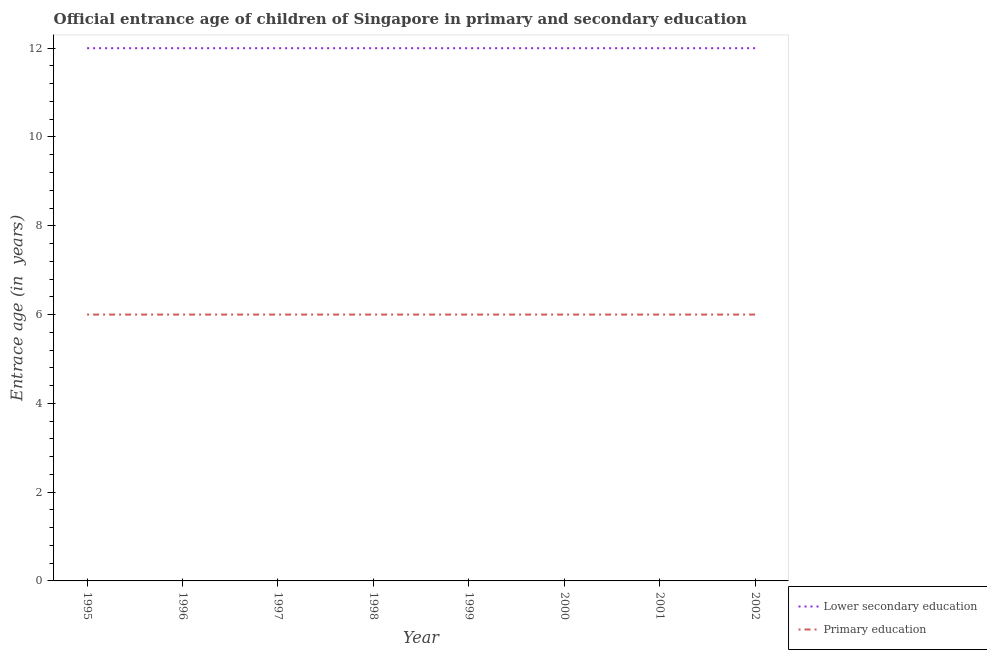How many different coloured lines are there?
Give a very brief answer. 2. Does the line corresponding to entrance age of children in lower secondary education intersect with the line corresponding to entrance age of chiildren in primary education?
Give a very brief answer. No. What is the entrance age of chiildren in primary education in 1995?
Provide a succinct answer. 6. Across all years, what is the maximum entrance age of children in lower secondary education?
Offer a terse response. 12. Across all years, what is the minimum entrance age of chiildren in primary education?
Offer a terse response. 6. What is the total entrance age of chiildren in primary education in the graph?
Your answer should be compact. 48. What is the difference between the entrance age of chiildren in primary education in 1999 and that in 2000?
Your response must be concise. 0. What is the difference between the entrance age of chiildren in primary education in 1996 and the entrance age of children in lower secondary education in 1999?
Your answer should be very brief. -6. What is the average entrance age of children in lower secondary education per year?
Your answer should be compact. 12. In the year 2000, what is the difference between the entrance age of chiildren in primary education and entrance age of children in lower secondary education?
Ensure brevity in your answer.  -6. In how many years, is the entrance age of children in lower secondary education greater than 6 years?
Offer a terse response. 8. Is the entrance age of children in lower secondary education in 1995 less than that in 1998?
Your response must be concise. No. What is the difference between the highest and the second highest entrance age of children in lower secondary education?
Keep it short and to the point. 0. Does the entrance age of chiildren in primary education monotonically increase over the years?
Your answer should be very brief. No. Is the entrance age of children in lower secondary education strictly less than the entrance age of chiildren in primary education over the years?
Your answer should be compact. No. How many years are there in the graph?
Offer a terse response. 8. What is the difference between two consecutive major ticks on the Y-axis?
Provide a short and direct response. 2. Are the values on the major ticks of Y-axis written in scientific E-notation?
Your response must be concise. No. Does the graph contain grids?
Offer a very short reply. No. How many legend labels are there?
Provide a short and direct response. 2. How are the legend labels stacked?
Your answer should be very brief. Vertical. What is the title of the graph?
Provide a short and direct response. Official entrance age of children of Singapore in primary and secondary education. What is the label or title of the Y-axis?
Provide a short and direct response. Entrace age (in  years). What is the Entrace age (in  years) in Lower secondary education in 1995?
Make the answer very short. 12. What is the Entrace age (in  years) in Lower secondary education in 2000?
Ensure brevity in your answer.  12. What is the Entrace age (in  years) in Lower secondary education in 2001?
Make the answer very short. 12. What is the Entrace age (in  years) of Lower secondary education in 2002?
Your response must be concise. 12. Across all years, what is the minimum Entrace age (in  years) in Primary education?
Provide a short and direct response. 6. What is the total Entrace age (in  years) of Lower secondary education in the graph?
Offer a very short reply. 96. What is the difference between the Entrace age (in  years) of Lower secondary education in 1995 and that in 1996?
Your answer should be very brief. 0. What is the difference between the Entrace age (in  years) in Primary education in 1995 and that in 1996?
Provide a short and direct response. 0. What is the difference between the Entrace age (in  years) in Primary education in 1995 and that in 1997?
Your answer should be very brief. 0. What is the difference between the Entrace age (in  years) in Lower secondary education in 1995 and that in 1998?
Give a very brief answer. 0. What is the difference between the Entrace age (in  years) of Primary education in 1995 and that in 1998?
Ensure brevity in your answer.  0. What is the difference between the Entrace age (in  years) of Primary education in 1995 and that in 1999?
Make the answer very short. 0. What is the difference between the Entrace age (in  years) of Lower secondary education in 1995 and that in 2000?
Your answer should be compact. 0. What is the difference between the Entrace age (in  years) of Lower secondary education in 1995 and that in 2001?
Give a very brief answer. 0. What is the difference between the Entrace age (in  years) of Primary education in 1995 and that in 2001?
Make the answer very short. 0. What is the difference between the Entrace age (in  years) in Lower secondary education in 1995 and that in 2002?
Give a very brief answer. 0. What is the difference between the Entrace age (in  years) in Primary education in 1996 and that in 1997?
Make the answer very short. 0. What is the difference between the Entrace age (in  years) in Lower secondary education in 1996 and that in 1999?
Give a very brief answer. 0. What is the difference between the Entrace age (in  years) of Lower secondary education in 1996 and that in 2000?
Give a very brief answer. 0. What is the difference between the Entrace age (in  years) in Lower secondary education in 1996 and that in 2002?
Your answer should be compact. 0. What is the difference between the Entrace age (in  years) of Lower secondary education in 1997 and that in 1998?
Keep it short and to the point. 0. What is the difference between the Entrace age (in  years) in Primary education in 1997 and that in 1998?
Make the answer very short. 0. What is the difference between the Entrace age (in  years) in Primary education in 1997 and that in 1999?
Keep it short and to the point. 0. What is the difference between the Entrace age (in  years) of Primary education in 1997 and that in 2000?
Your response must be concise. 0. What is the difference between the Entrace age (in  years) of Lower secondary education in 1997 and that in 2001?
Make the answer very short. 0. What is the difference between the Entrace age (in  years) of Lower secondary education in 1997 and that in 2002?
Provide a short and direct response. 0. What is the difference between the Entrace age (in  years) in Lower secondary education in 1998 and that in 1999?
Make the answer very short. 0. What is the difference between the Entrace age (in  years) in Primary education in 1998 and that in 2000?
Your answer should be very brief. 0. What is the difference between the Entrace age (in  years) of Lower secondary education in 1998 and that in 2001?
Keep it short and to the point. 0. What is the difference between the Entrace age (in  years) in Primary education in 1999 and that in 2002?
Ensure brevity in your answer.  0. What is the difference between the Entrace age (in  years) in Lower secondary education in 2000 and that in 2001?
Keep it short and to the point. 0. What is the difference between the Entrace age (in  years) of Primary education in 2000 and that in 2002?
Offer a terse response. 0. What is the difference between the Entrace age (in  years) in Lower secondary education in 1995 and the Entrace age (in  years) in Primary education in 1999?
Keep it short and to the point. 6. What is the difference between the Entrace age (in  years) in Lower secondary education in 1995 and the Entrace age (in  years) in Primary education in 2000?
Keep it short and to the point. 6. What is the difference between the Entrace age (in  years) in Lower secondary education in 1995 and the Entrace age (in  years) in Primary education in 2001?
Your response must be concise. 6. What is the difference between the Entrace age (in  years) in Lower secondary education in 1995 and the Entrace age (in  years) in Primary education in 2002?
Give a very brief answer. 6. What is the difference between the Entrace age (in  years) in Lower secondary education in 1996 and the Entrace age (in  years) in Primary education in 1998?
Your answer should be compact. 6. What is the difference between the Entrace age (in  years) of Lower secondary education in 1996 and the Entrace age (in  years) of Primary education in 1999?
Your response must be concise. 6. What is the difference between the Entrace age (in  years) of Lower secondary education in 1998 and the Entrace age (in  years) of Primary education in 1999?
Keep it short and to the point. 6. What is the difference between the Entrace age (in  years) of Lower secondary education in 1998 and the Entrace age (in  years) of Primary education in 2001?
Offer a very short reply. 6. What is the difference between the Entrace age (in  years) of Lower secondary education in 1998 and the Entrace age (in  years) of Primary education in 2002?
Offer a very short reply. 6. What is the difference between the Entrace age (in  years) of Lower secondary education in 1999 and the Entrace age (in  years) of Primary education in 2001?
Ensure brevity in your answer.  6. What is the difference between the Entrace age (in  years) of Lower secondary education in 1999 and the Entrace age (in  years) of Primary education in 2002?
Offer a very short reply. 6. What is the difference between the Entrace age (in  years) of Lower secondary education in 2000 and the Entrace age (in  years) of Primary education in 2001?
Your answer should be very brief. 6. What is the difference between the Entrace age (in  years) in Lower secondary education in 2000 and the Entrace age (in  years) in Primary education in 2002?
Provide a succinct answer. 6. What is the average Entrace age (in  years) in Lower secondary education per year?
Provide a succinct answer. 12. What is the average Entrace age (in  years) in Primary education per year?
Make the answer very short. 6. In the year 1995, what is the difference between the Entrace age (in  years) in Lower secondary education and Entrace age (in  years) in Primary education?
Your response must be concise. 6. In the year 1999, what is the difference between the Entrace age (in  years) of Lower secondary education and Entrace age (in  years) of Primary education?
Give a very brief answer. 6. What is the ratio of the Entrace age (in  years) of Primary education in 1995 to that in 1996?
Ensure brevity in your answer.  1. What is the ratio of the Entrace age (in  years) in Lower secondary education in 1995 to that in 1997?
Your answer should be compact. 1. What is the ratio of the Entrace age (in  years) of Primary education in 1995 to that in 1997?
Provide a succinct answer. 1. What is the ratio of the Entrace age (in  years) in Lower secondary education in 1995 to that in 2000?
Offer a very short reply. 1. What is the ratio of the Entrace age (in  years) of Lower secondary education in 1995 to that in 2001?
Your answer should be compact. 1. What is the ratio of the Entrace age (in  years) in Primary education in 1995 to that in 2001?
Keep it short and to the point. 1. What is the ratio of the Entrace age (in  years) in Primary education in 1995 to that in 2002?
Your answer should be compact. 1. What is the ratio of the Entrace age (in  years) in Lower secondary education in 1996 to that in 1997?
Make the answer very short. 1. What is the ratio of the Entrace age (in  years) in Primary education in 1996 to that in 1997?
Your answer should be compact. 1. What is the ratio of the Entrace age (in  years) in Primary education in 1996 to that in 1998?
Your response must be concise. 1. What is the ratio of the Entrace age (in  years) of Primary education in 1996 to that in 1999?
Provide a succinct answer. 1. What is the ratio of the Entrace age (in  years) of Lower secondary education in 1996 to that in 2000?
Provide a short and direct response. 1. What is the ratio of the Entrace age (in  years) of Primary education in 1996 to that in 2000?
Provide a succinct answer. 1. What is the ratio of the Entrace age (in  years) of Lower secondary education in 1996 to that in 2001?
Give a very brief answer. 1. What is the ratio of the Entrace age (in  years) of Primary education in 1996 to that in 2001?
Your answer should be very brief. 1. What is the ratio of the Entrace age (in  years) of Primary education in 1996 to that in 2002?
Make the answer very short. 1. What is the ratio of the Entrace age (in  years) in Primary education in 1997 to that in 1999?
Give a very brief answer. 1. What is the ratio of the Entrace age (in  years) of Primary education in 1997 to that in 2001?
Provide a short and direct response. 1. What is the ratio of the Entrace age (in  years) in Lower secondary education in 1997 to that in 2002?
Your answer should be very brief. 1. What is the ratio of the Entrace age (in  years) of Primary education in 1997 to that in 2002?
Provide a succinct answer. 1. What is the ratio of the Entrace age (in  years) of Lower secondary education in 1998 to that in 1999?
Offer a terse response. 1. What is the ratio of the Entrace age (in  years) in Primary education in 1998 to that in 1999?
Your response must be concise. 1. What is the ratio of the Entrace age (in  years) of Lower secondary education in 1998 to that in 2000?
Make the answer very short. 1. What is the ratio of the Entrace age (in  years) of Primary education in 1998 to that in 2000?
Keep it short and to the point. 1. What is the ratio of the Entrace age (in  years) in Lower secondary education in 1998 to that in 2002?
Ensure brevity in your answer.  1. What is the ratio of the Entrace age (in  years) in Primary education in 1998 to that in 2002?
Offer a terse response. 1. What is the ratio of the Entrace age (in  years) of Primary education in 1999 to that in 2000?
Offer a terse response. 1. What is the ratio of the Entrace age (in  years) in Primary education in 1999 to that in 2002?
Keep it short and to the point. 1. What is the ratio of the Entrace age (in  years) of Lower secondary education in 2000 to that in 2002?
Your response must be concise. 1. What is the ratio of the Entrace age (in  years) of Lower secondary education in 2001 to that in 2002?
Your answer should be very brief. 1. What is the ratio of the Entrace age (in  years) in Primary education in 2001 to that in 2002?
Your answer should be very brief. 1. What is the difference between the highest and the second highest Entrace age (in  years) of Lower secondary education?
Provide a short and direct response. 0. What is the difference between the highest and the lowest Entrace age (in  years) of Lower secondary education?
Keep it short and to the point. 0. 